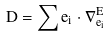<formula> <loc_0><loc_0><loc_500><loc_500>D = \sum e _ { i } \cdot \nabla _ { e _ { i } } ^ { E }</formula> 